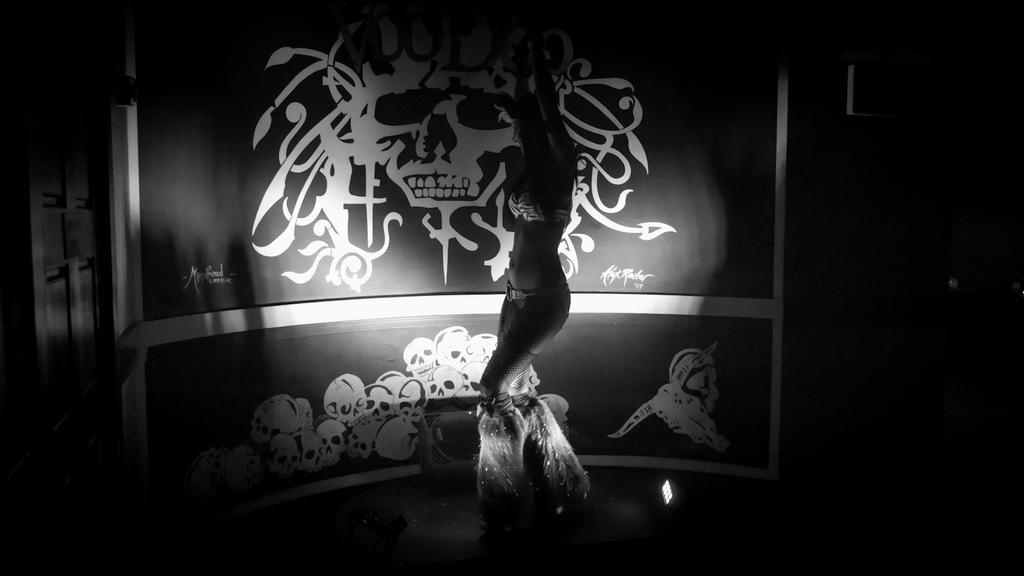Can you describe this image briefly? In this image we can see the dark picture. And there is a person dancing. And at the back there is a poster with text and images. 